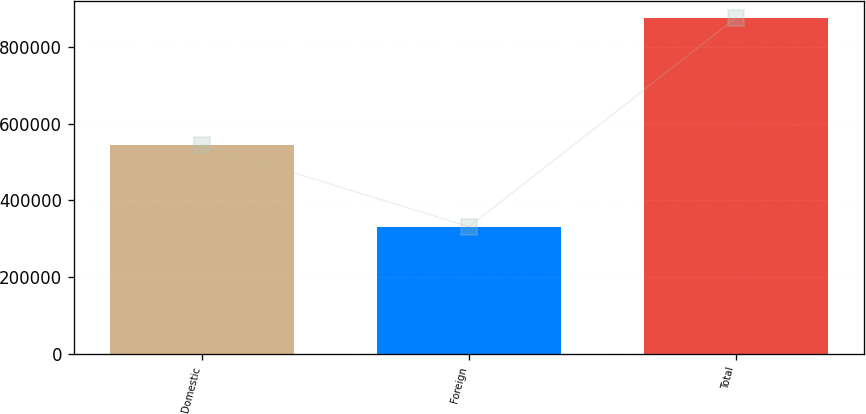Convert chart. <chart><loc_0><loc_0><loc_500><loc_500><bar_chart><fcel>Domestic<fcel>Foreign<fcel>Total<nl><fcel>544900<fcel>330915<fcel>875815<nl></chart> 